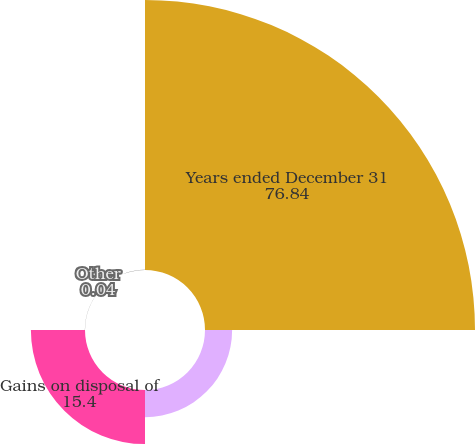Convert chart to OTSL. <chart><loc_0><loc_0><loc_500><loc_500><pie_chart><fcel>Years ended December 31<fcel>Realized gain (loss) on sale<fcel>Gains on disposal of<fcel>Other<nl><fcel>76.84%<fcel>7.72%<fcel>15.4%<fcel>0.04%<nl></chart> 